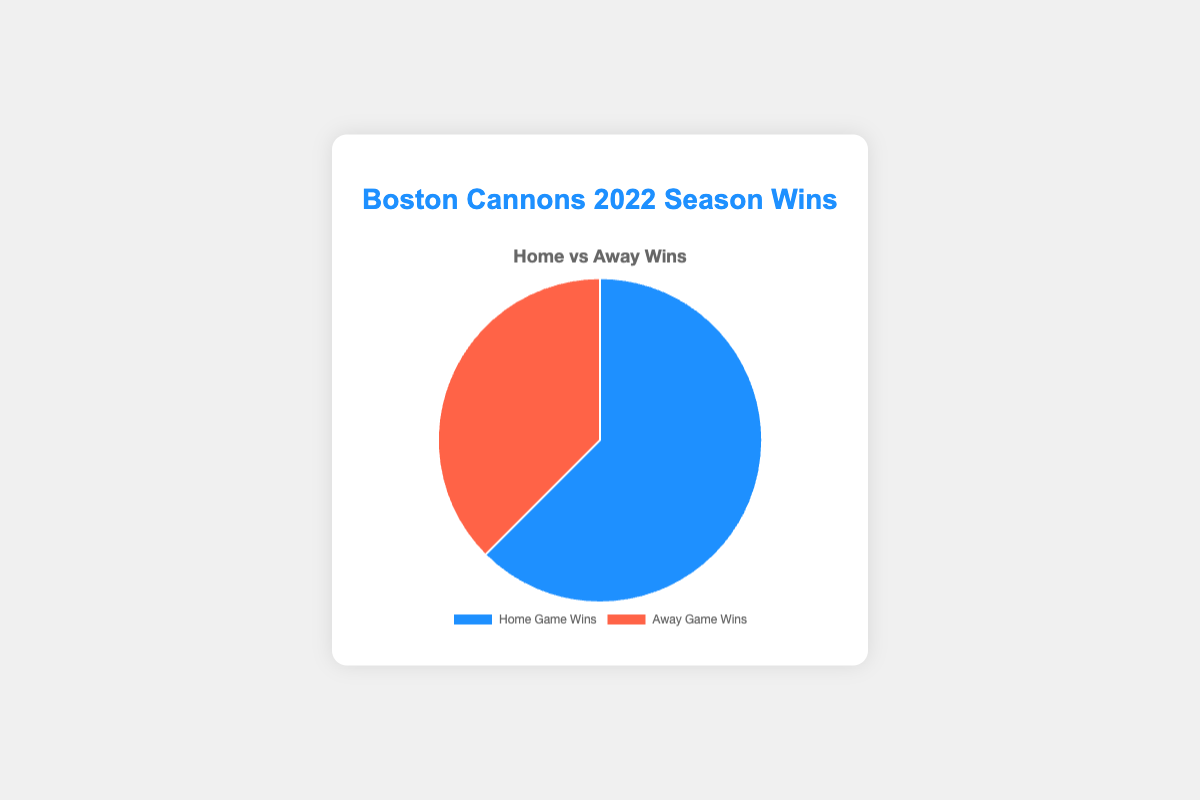What percentage of total wins were home game wins? The total number of wins is 5 (home) + 3 (away) = 8 wins. The percentage of home game wins is (5/8) * 100 = 62.5%.
Answer: 62.5% How many more home game wins did the Boston Cannons have compared to away game wins? The number of home game wins is 5 and away game wins is 3. The difference is 5 - 3 = 2.
Answer: 2 If the total number of wins doubled, how many home game wins would the Boston Cannons have if the ratio remains the same? The current ratio of home to away wins is 5:3. If the total wins double, the new total is 8 * 2 = 16. Using the same ratio: (5/8) * 16 = 10 home game wins.
Answer: 10 Which category has a larger share of wins? The pie chart shows that home game wins are visually represented with a larger segment compared to away game wins.
Answer: Home game wins What color represents the away game wins in the chart? The pie chart shows away game wins in a visually distinct color which is red.
Answer: Red What is the total number of wins for the Boston Cannons in the 2022 season? The combination of home game wins (5) and away game wins (3) gives a total of 5 + 3 = 8 wins.
Answer: 8 By what factor is the number of home game wins greater than the away game wins? The number of home game wins is 5 and away game wins is 3. The factor is calculated as 5/3.
Answer: 5/3 What is the ratio of home game wins to the total wins? The total wins are 8. The home game wins are 5. The ratio is 5 to 8.
Answer: 5:8 